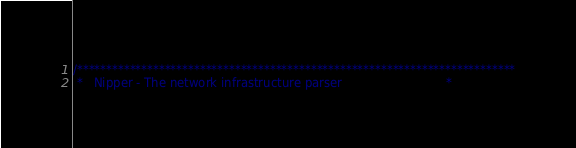<code> <loc_0><loc_0><loc_500><loc_500><_C_>/***************************************************************************
 *   Nipper - The network infrastructure parser                            *</code> 